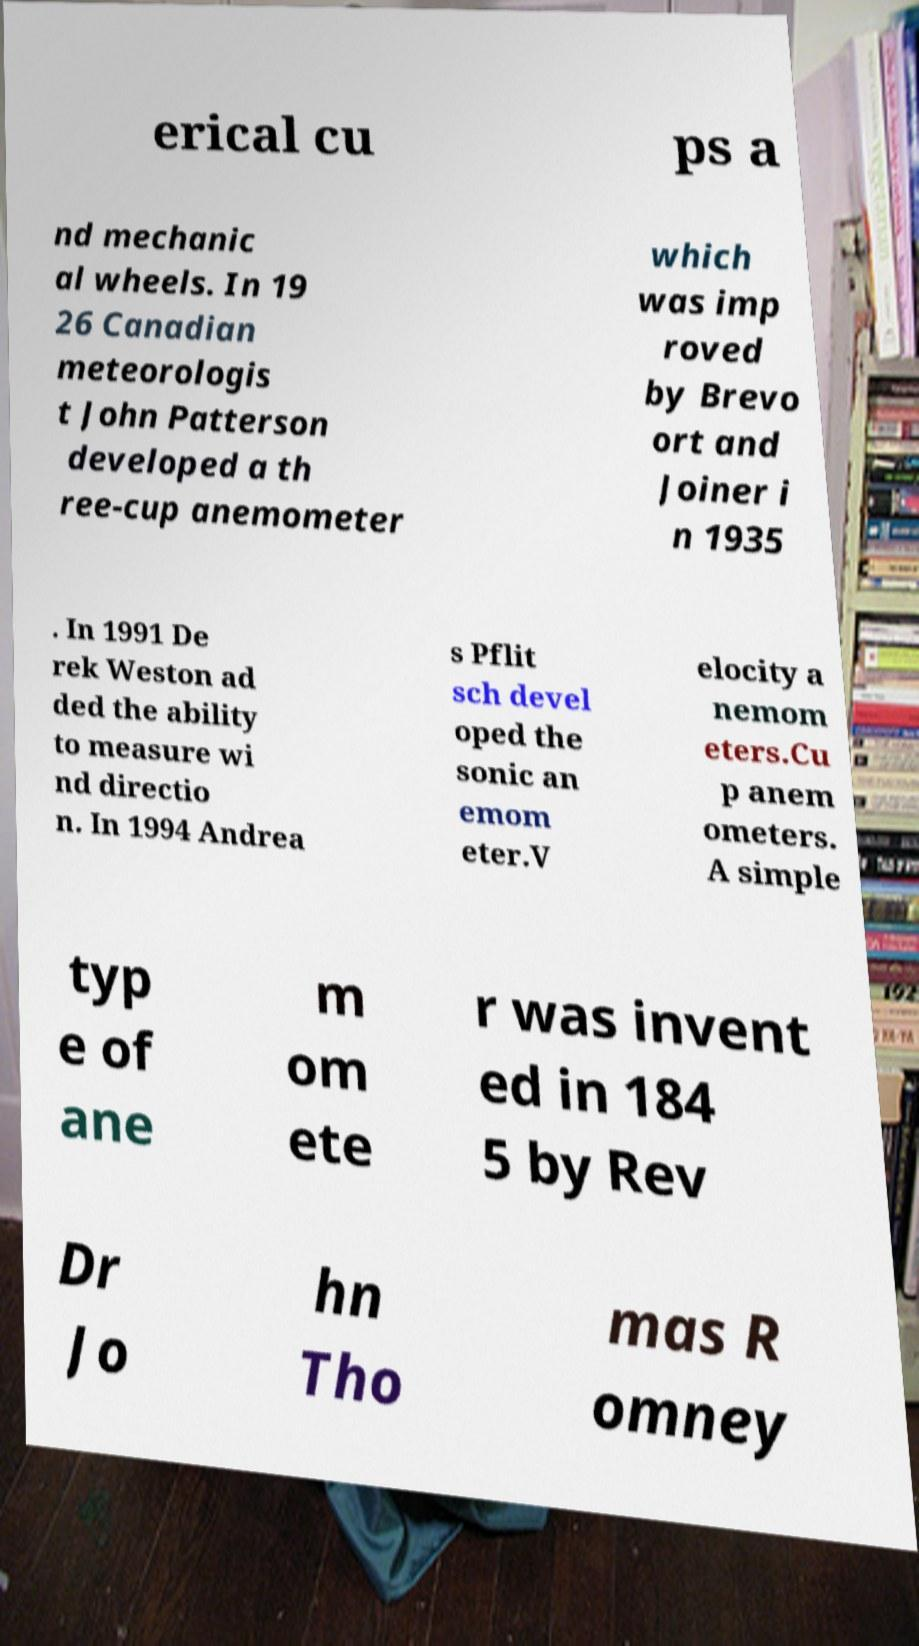Could you extract and type out the text from this image? erical cu ps a nd mechanic al wheels. In 19 26 Canadian meteorologis t John Patterson developed a th ree-cup anemometer which was imp roved by Brevo ort and Joiner i n 1935 . In 1991 De rek Weston ad ded the ability to measure wi nd directio n. In 1994 Andrea s Pflit sch devel oped the sonic an emom eter.V elocity a nemom eters.Cu p anem ometers. A simple typ e of ane m om ete r was invent ed in 184 5 by Rev Dr Jo hn Tho mas R omney 